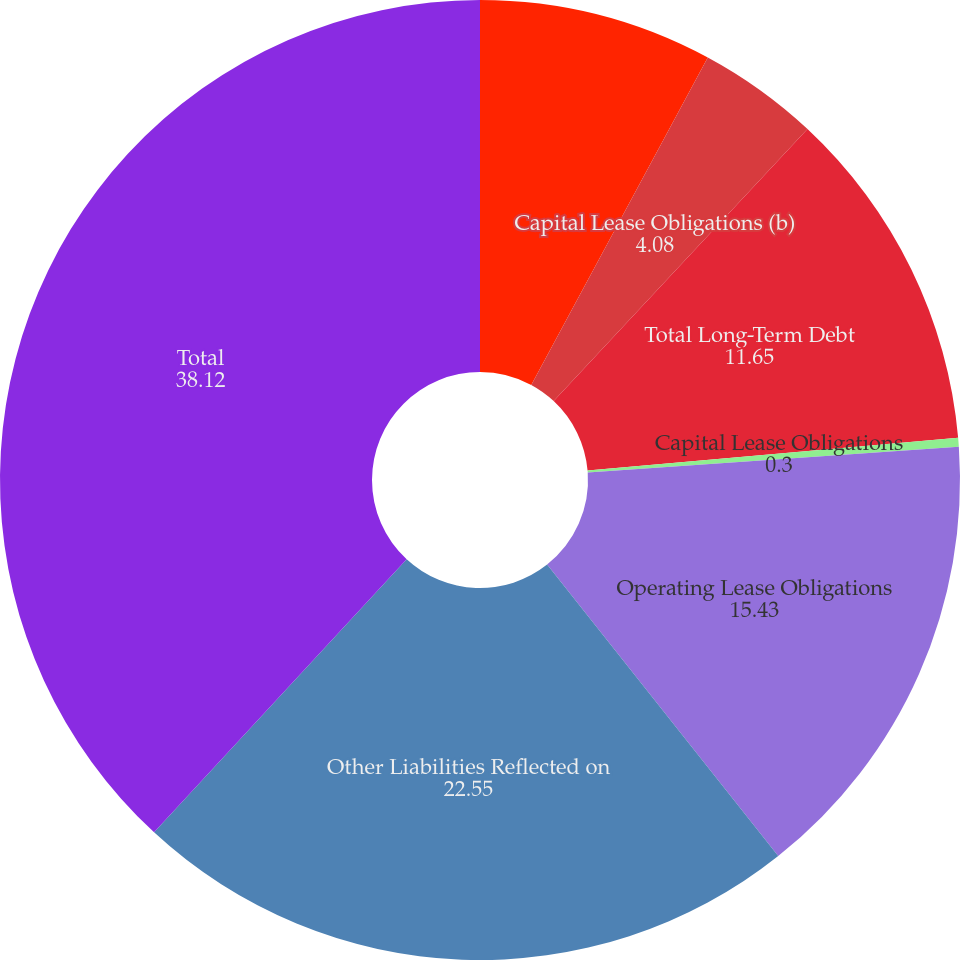<chart> <loc_0><loc_0><loc_500><loc_500><pie_chart><fcel>Long-Term Debt Obligations<fcel>Capital Lease Obligations (b)<fcel>Total Long-Term Debt<fcel>Capital Lease Obligations<fcel>Operating Lease Obligations<fcel>Other Liabilities Reflected on<fcel>Total<nl><fcel>7.87%<fcel>4.08%<fcel>11.65%<fcel>0.3%<fcel>15.43%<fcel>22.55%<fcel>38.12%<nl></chart> 